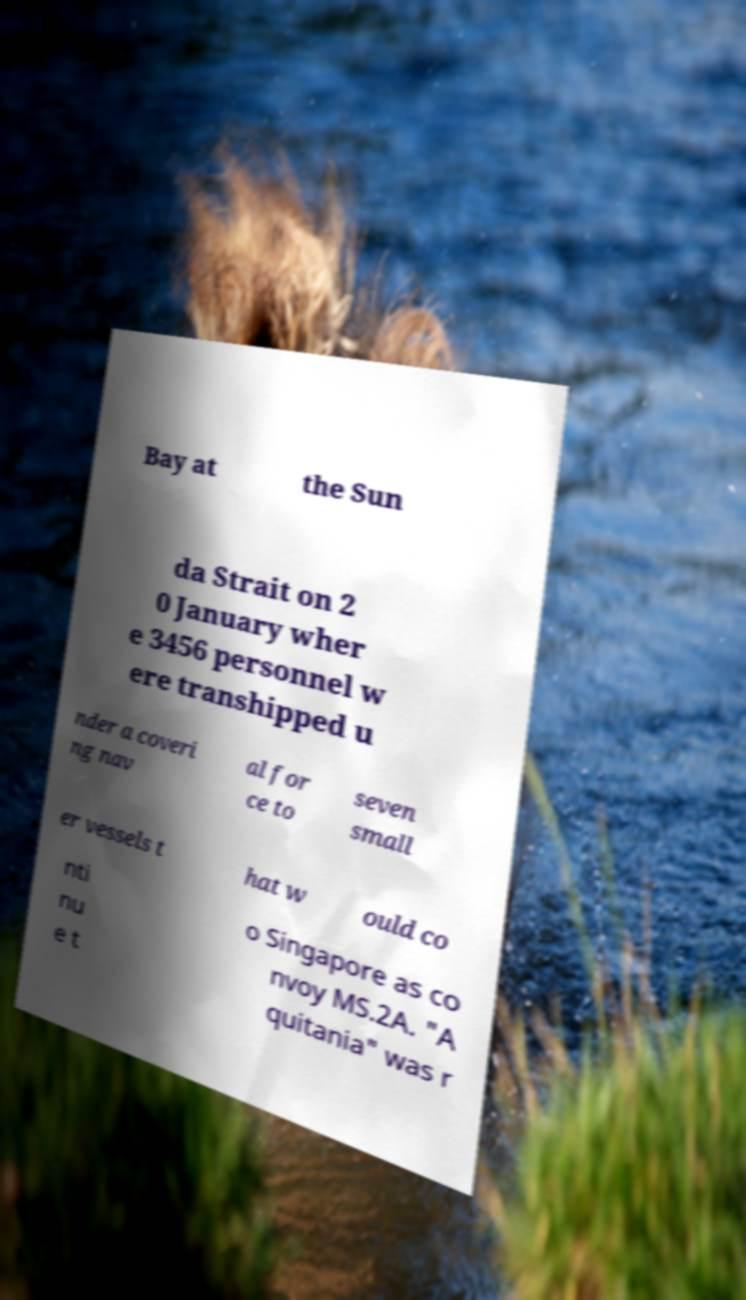Could you extract and type out the text from this image? Bay at the Sun da Strait on 2 0 January wher e 3456 personnel w ere transhipped u nder a coveri ng nav al for ce to seven small er vessels t hat w ould co nti nu e t o Singapore as co nvoy MS.2A. "A quitania" was r 